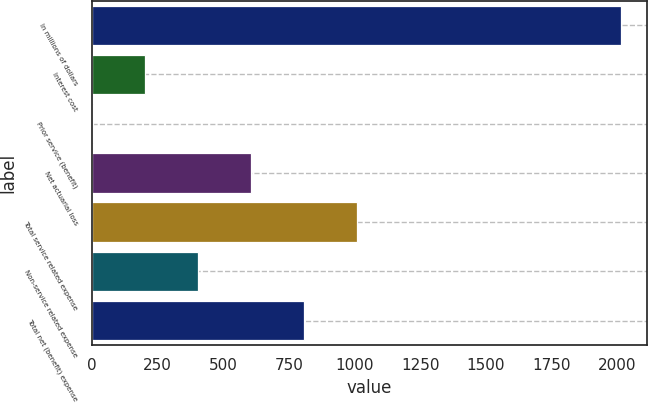Convert chart. <chart><loc_0><loc_0><loc_500><loc_500><bar_chart><fcel>In millions of dollars<fcel>Interest cost<fcel>Prior service (benefit)<fcel>Net actuarial loss<fcel>Total service related expense<fcel>Non-service related expense<fcel>Total net (benefit) expense<nl><fcel>2013<fcel>204<fcel>3<fcel>606<fcel>1008<fcel>405<fcel>807<nl></chart> 